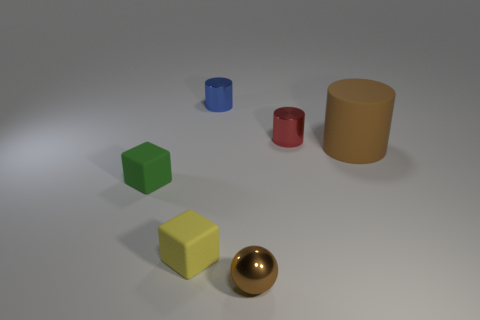Do the small shiny sphere and the big rubber cylinder have the same color?
Make the answer very short. Yes. The tiny object that is in front of the small red cylinder and to the right of the tiny yellow rubber block is what color?
Give a very brief answer. Brown. How many spheres are either tiny yellow matte things or large objects?
Offer a very short reply. 0. Are there fewer matte cylinders that are in front of the yellow matte cube than tiny brown shiny things?
Your answer should be very brief. Yes. The blue object that is the same material as the brown sphere is what shape?
Provide a short and direct response. Cylinder. What number of big matte cylinders have the same color as the big rubber object?
Your answer should be compact. 0. What number of things are either large yellow metal spheres or tiny green matte cubes?
Provide a succinct answer. 1. The block left of the rubber thing in front of the green cube is made of what material?
Make the answer very short. Rubber. Is there a big brown cylinder made of the same material as the ball?
Provide a succinct answer. No. There is a rubber thing on the right side of the tiny cylinder to the left of the tiny metallic thing that is to the right of the small brown object; what is its shape?
Keep it short and to the point. Cylinder. 